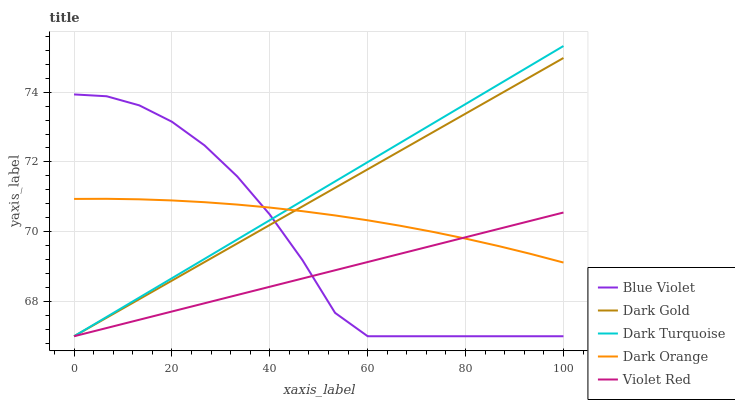Does Violet Red have the minimum area under the curve?
Answer yes or no. Yes. Does Dark Turquoise have the maximum area under the curve?
Answer yes or no. Yes. Does Dark Turquoise have the minimum area under the curve?
Answer yes or no. No. Does Violet Red have the maximum area under the curve?
Answer yes or no. No. Is Dark Turquoise the smoothest?
Answer yes or no. Yes. Is Blue Violet the roughest?
Answer yes or no. Yes. Is Violet Red the smoothest?
Answer yes or no. No. Is Violet Red the roughest?
Answer yes or no. No. Does Dark Turquoise have the lowest value?
Answer yes or no. Yes. Does Dark Turquoise have the highest value?
Answer yes or no. Yes. Does Violet Red have the highest value?
Answer yes or no. No. Does Dark Gold intersect Dark Orange?
Answer yes or no. Yes. Is Dark Gold less than Dark Orange?
Answer yes or no. No. Is Dark Gold greater than Dark Orange?
Answer yes or no. No. 